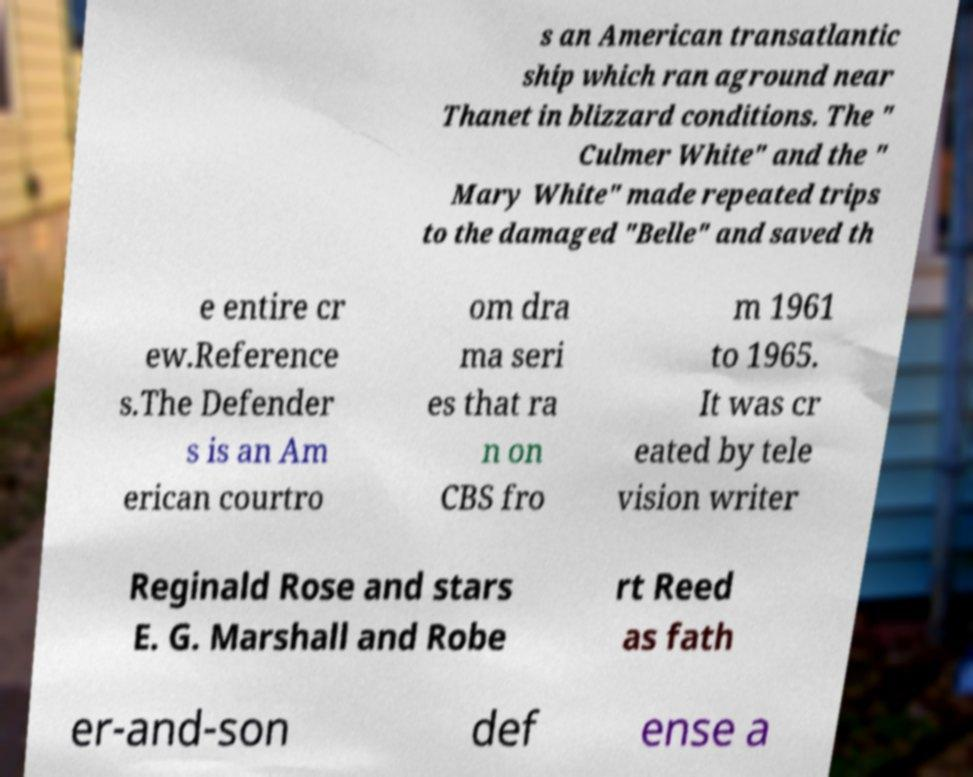Please read and relay the text visible in this image. What does it say? s an American transatlantic ship which ran aground near Thanet in blizzard conditions. The " Culmer White" and the " Mary White" made repeated trips to the damaged "Belle" and saved th e entire cr ew.Reference s.The Defender s is an Am erican courtro om dra ma seri es that ra n on CBS fro m 1961 to 1965. It was cr eated by tele vision writer Reginald Rose and stars E. G. Marshall and Robe rt Reed as fath er-and-son def ense a 